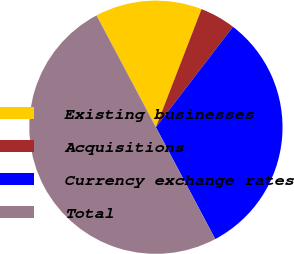Convert chart. <chart><loc_0><loc_0><loc_500><loc_500><pie_chart><fcel>Existing businesses<fcel>Acquisitions<fcel>Currency exchange rates<fcel>Total<nl><fcel>13.64%<fcel>4.55%<fcel>31.82%<fcel>50.0%<nl></chart> 